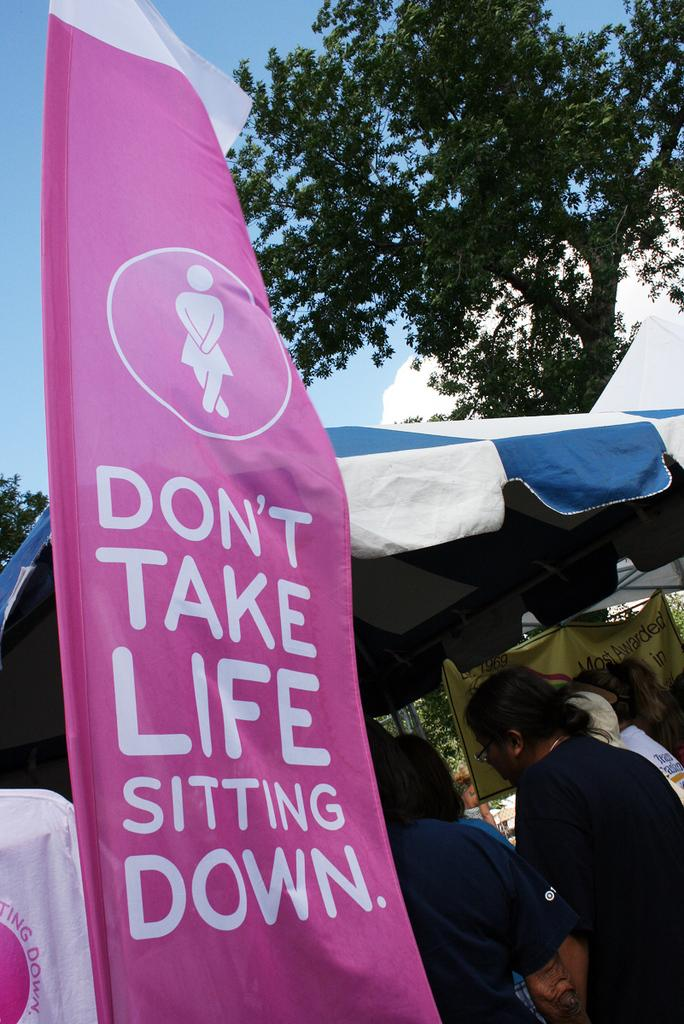What can be seen on the left side of the image? There is a poster on the left side of the image with text written on it. What is located on the right side of the image? There are ladies and a tent on the right side of the image. There is also a tree on the right side of the image. What is the purpose of the text on the poster? The purpose of the text on the poster cannot be determined from the image alone. What type of doll is sitting on the tree branch in the image? There is no doll present in the image. What does the stick say in the image? There is no stick with text in the image. 